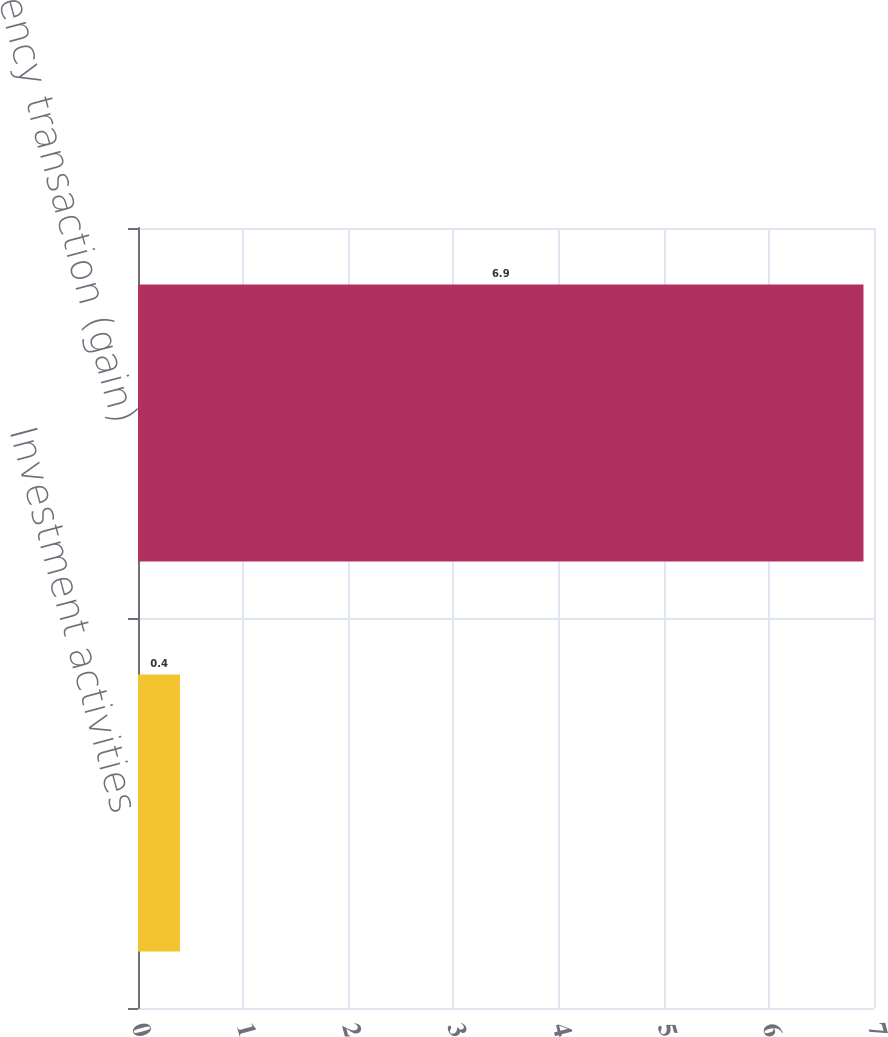Convert chart to OTSL. <chart><loc_0><loc_0><loc_500><loc_500><bar_chart><fcel>Investment activities<fcel>Currency transaction (gain)<nl><fcel>0.4<fcel>6.9<nl></chart> 